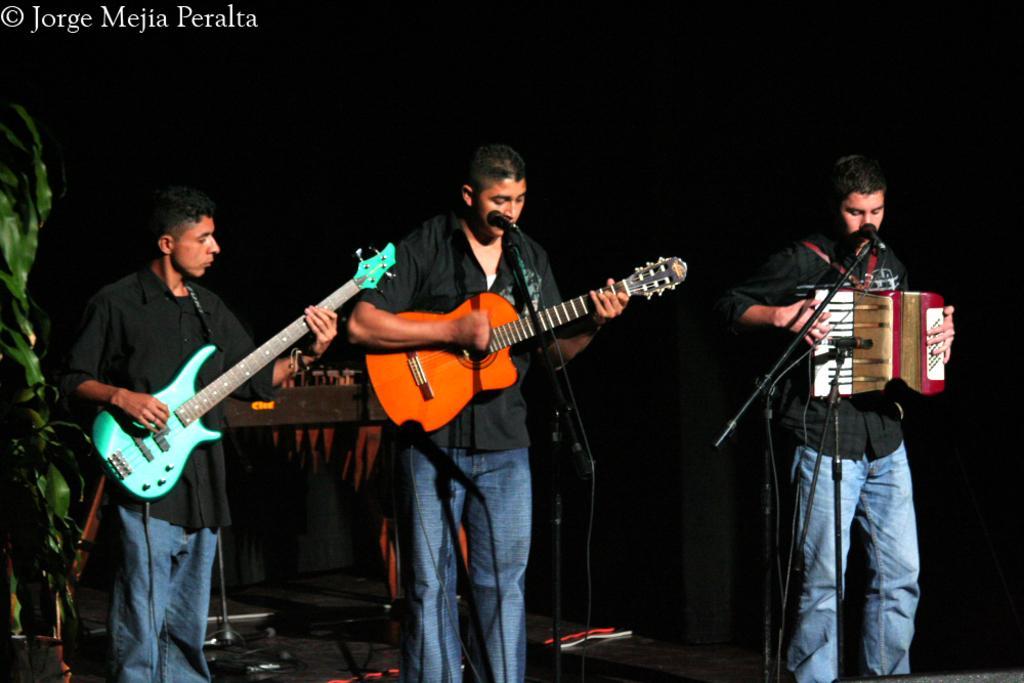Please provide a concise description of this image. The picture is taken inside a club, there are three men standing in a row first two are playing guitar, the second person is also singing a song, the third person is playing harmonium,in the background there is a music system to the left side there is a tree. 